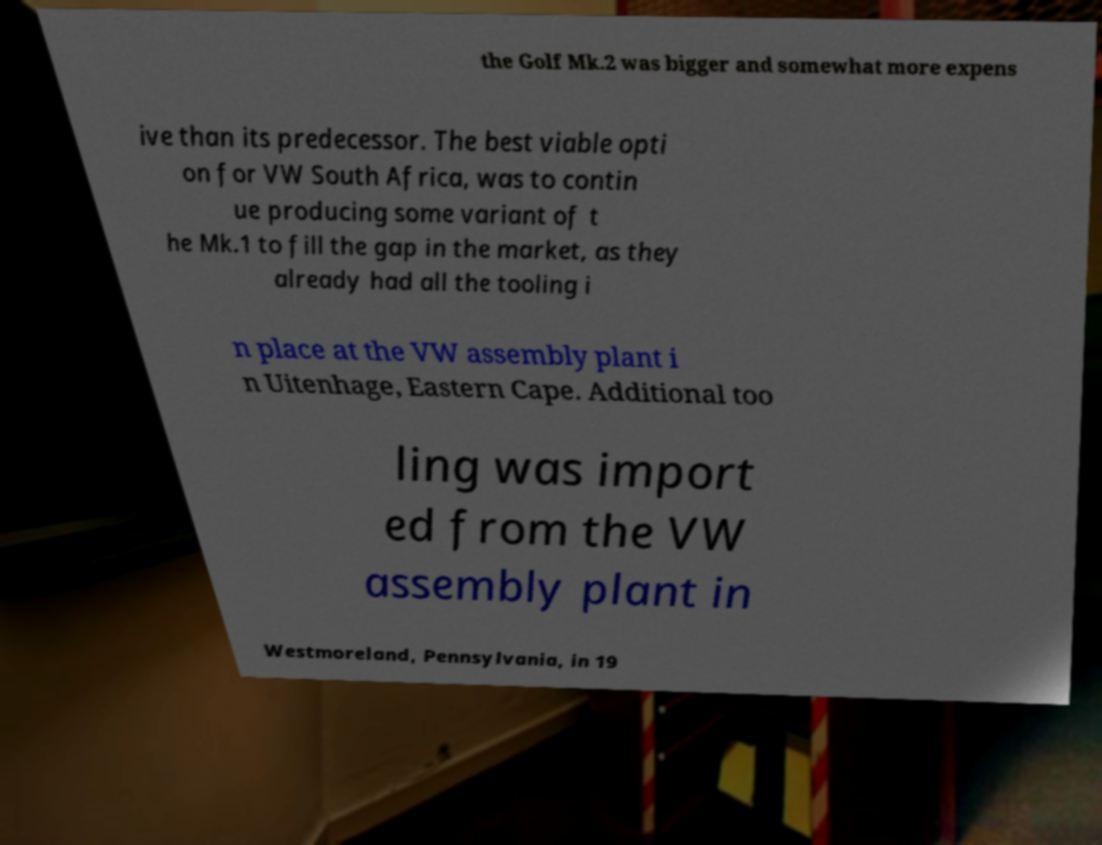There's text embedded in this image that I need extracted. Can you transcribe it verbatim? the Golf Mk.2 was bigger and somewhat more expens ive than its predecessor. The best viable opti on for VW South Africa, was to contin ue producing some variant of t he Mk.1 to fill the gap in the market, as they already had all the tooling i n place at the VW assembly plant i n Uitenhage, Eastern Cape. Additional too ling was import ed from the VW assembly plant in Westmoreland, Pennsylvania, in 19 